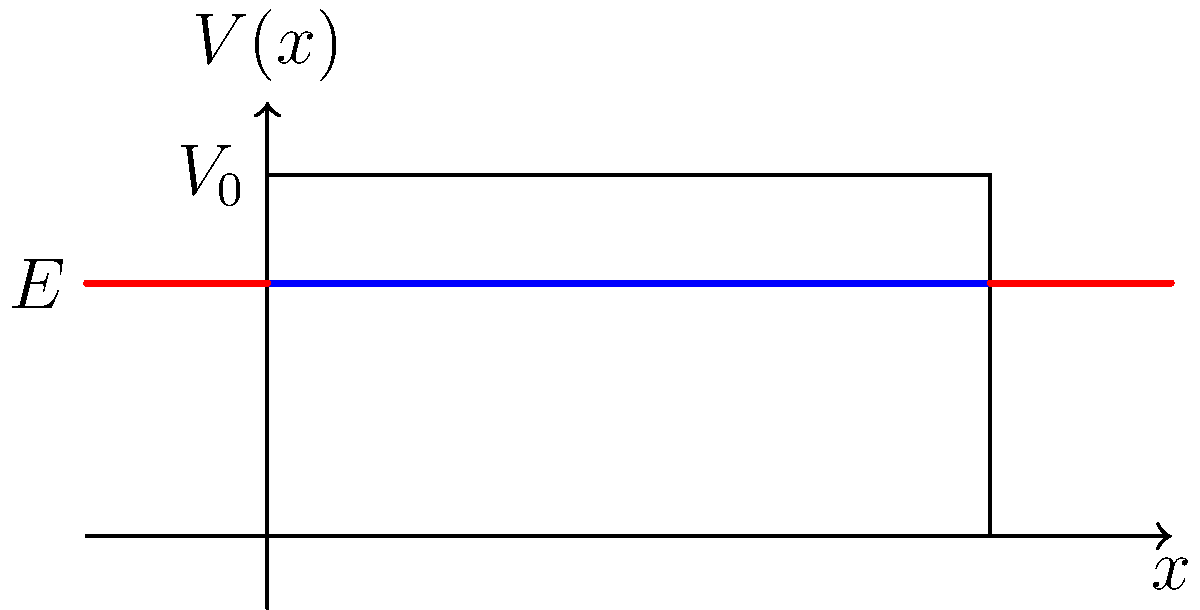In the energy diagram above, which represents quantum tunneling through a potential barrier, what is the nature of the wave function in regions I, II, and III for a particle with energy $E < V_0$? Explain how the wave function behaves in each region and at the boundaries. To understand the nature of the wave function in each region, we need to consider the Schrödinger equation and its solutions:

1. Region I (x < 0):
   - The particle has energy E in a region with no potential (V = 0).
   - The wave function is a propagating wave: $\psi_I(x) = Ae^{ikx} + Be^{-ikx}$
   - Where $k = \sqrt{\frac{2mE}{\hbar^2}}$

2. Region II (0 < x < L):
   - The particle encounters a potential barrier (V = V₀ > E).
   - The wave function is an evanescent wave: $\psi_{II}(x) = Ce^{-\kappa x} + De^{\kappa x}$
   - Where $\kappa = \sqrt{\frac{2m(V_0-E)}{\hbar^2}}$

3. Region III (x > L):
   - The particle is back in a region with no potential (V = 0).
   - The wave function is again a propagating wave: $\psi_{III}(x) = Fe^{ikx}$

At the boundaries (x = 0 and x = L):
- The wave function and its first derivative must be continuous.
- This ensures smooth transitions between regions.

Key observations:
- In region II, the wave function decays exponentially but doesn't become zero.
- There's a non-zero probability of finding the particle in region III, demonstrating tunneling.
- The amplitude of the wave in region III is smaller than in region I, as only a fraction of particles tunnel through.
Answer: I: Propagating wave, II: Evanescent wave, III: Propagating wave with reduced amplitude 